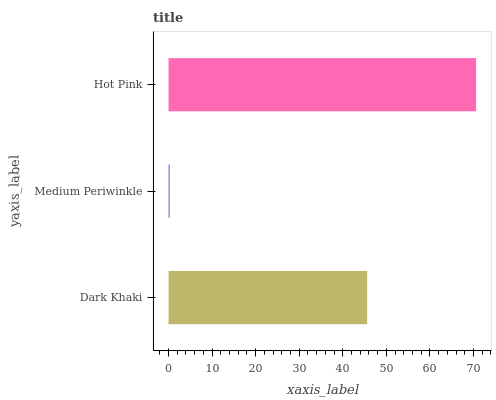Is Medium Periwinkle the minimum?
Answer yes or no. Yes. Is Hot Pink the maximum?
Answer yes or no. Yes. Is Hot Pink the minimum?
Answer yes or no. No. Is Medium Periwinkle the maximum?
Answer yes or no. No. Is Hot Pink greater than Medium Periwinkle?
Answer yes or no. Yes. Is Medium Periwinkle less than Hot Pink?
Answer yes or no. Yes. Is Medium Periwinkle greater than Hot Pink?
Answer yes or no. No. Is Hot Pink less than Medium Periwinkle?
Answer yes or no. No. Is Dark Khaki the high median?
Answer yes or no. Yes. Is Dark Khaki the low median?
Answer yes or no. Yes. Is Medium Periwinkle the high median?
Answer yes or no. No. Is Medium Periwinkle the low median?
Answer yes or no. No. 